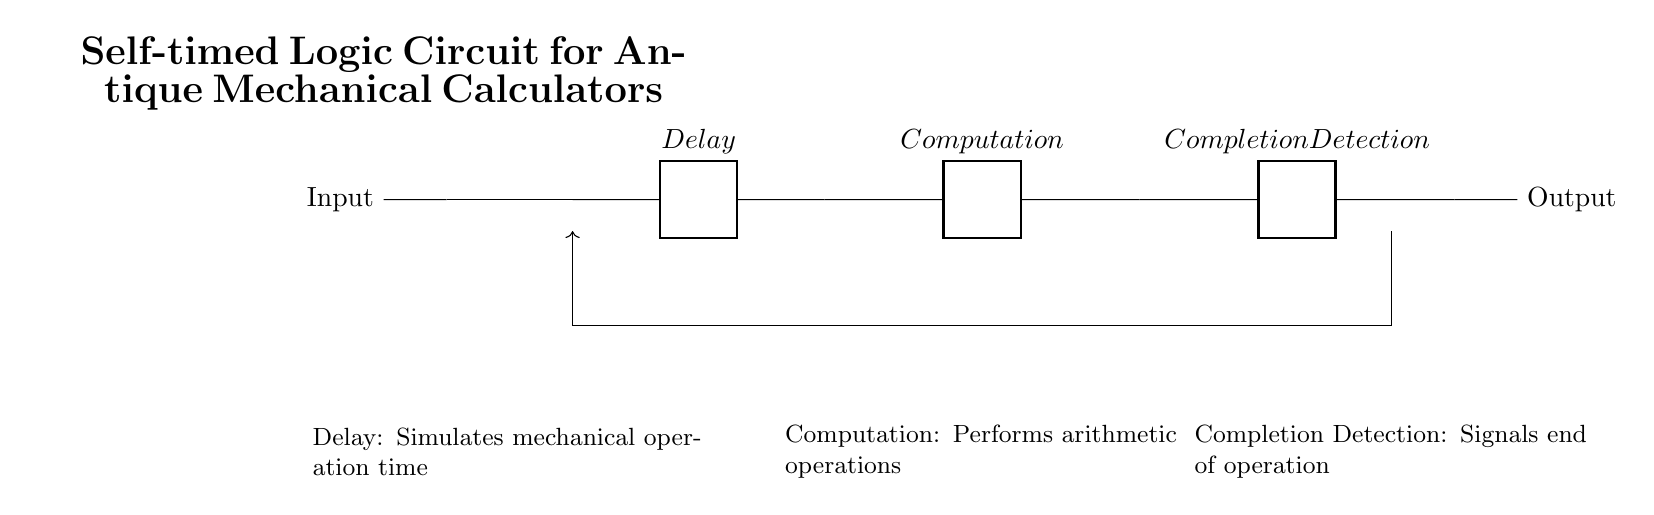What is the input component in this circuit? The input component is represented as "Input" in the diagram and is connected to the buffer.
Answer: Input What type of logic circuit is this? This is a self-timed logic circuit, indicated by the presence of delay, computation, and completion detection components that do not require a clock signal.
Answer: Self-timed How many main blocks are present in the circuit? There are three main blocks: Delay, Computation, and Completion Detection. Each performs a distinct function within the circuit.
Answer: Three What does the feedback loop signify in this circuit? The feedback loop signifies that there is a connection from the completion detection back to the delay, allowing the circuit to indicate when an operation has finished and possibly trigger a reset or repeat operation.
Answer: Feedback loop What component simulates mechanical operation time? The component that simulates mechanical operation time is labeled as "Delay" in the circuit.
Answer: Delay What is the purpose of the completion detection? The purpose of the completion detection is to signal the end of an operation, allowing the circuit to proceed to the next step in the calculation or operation.
Answer: Signal end of operation 